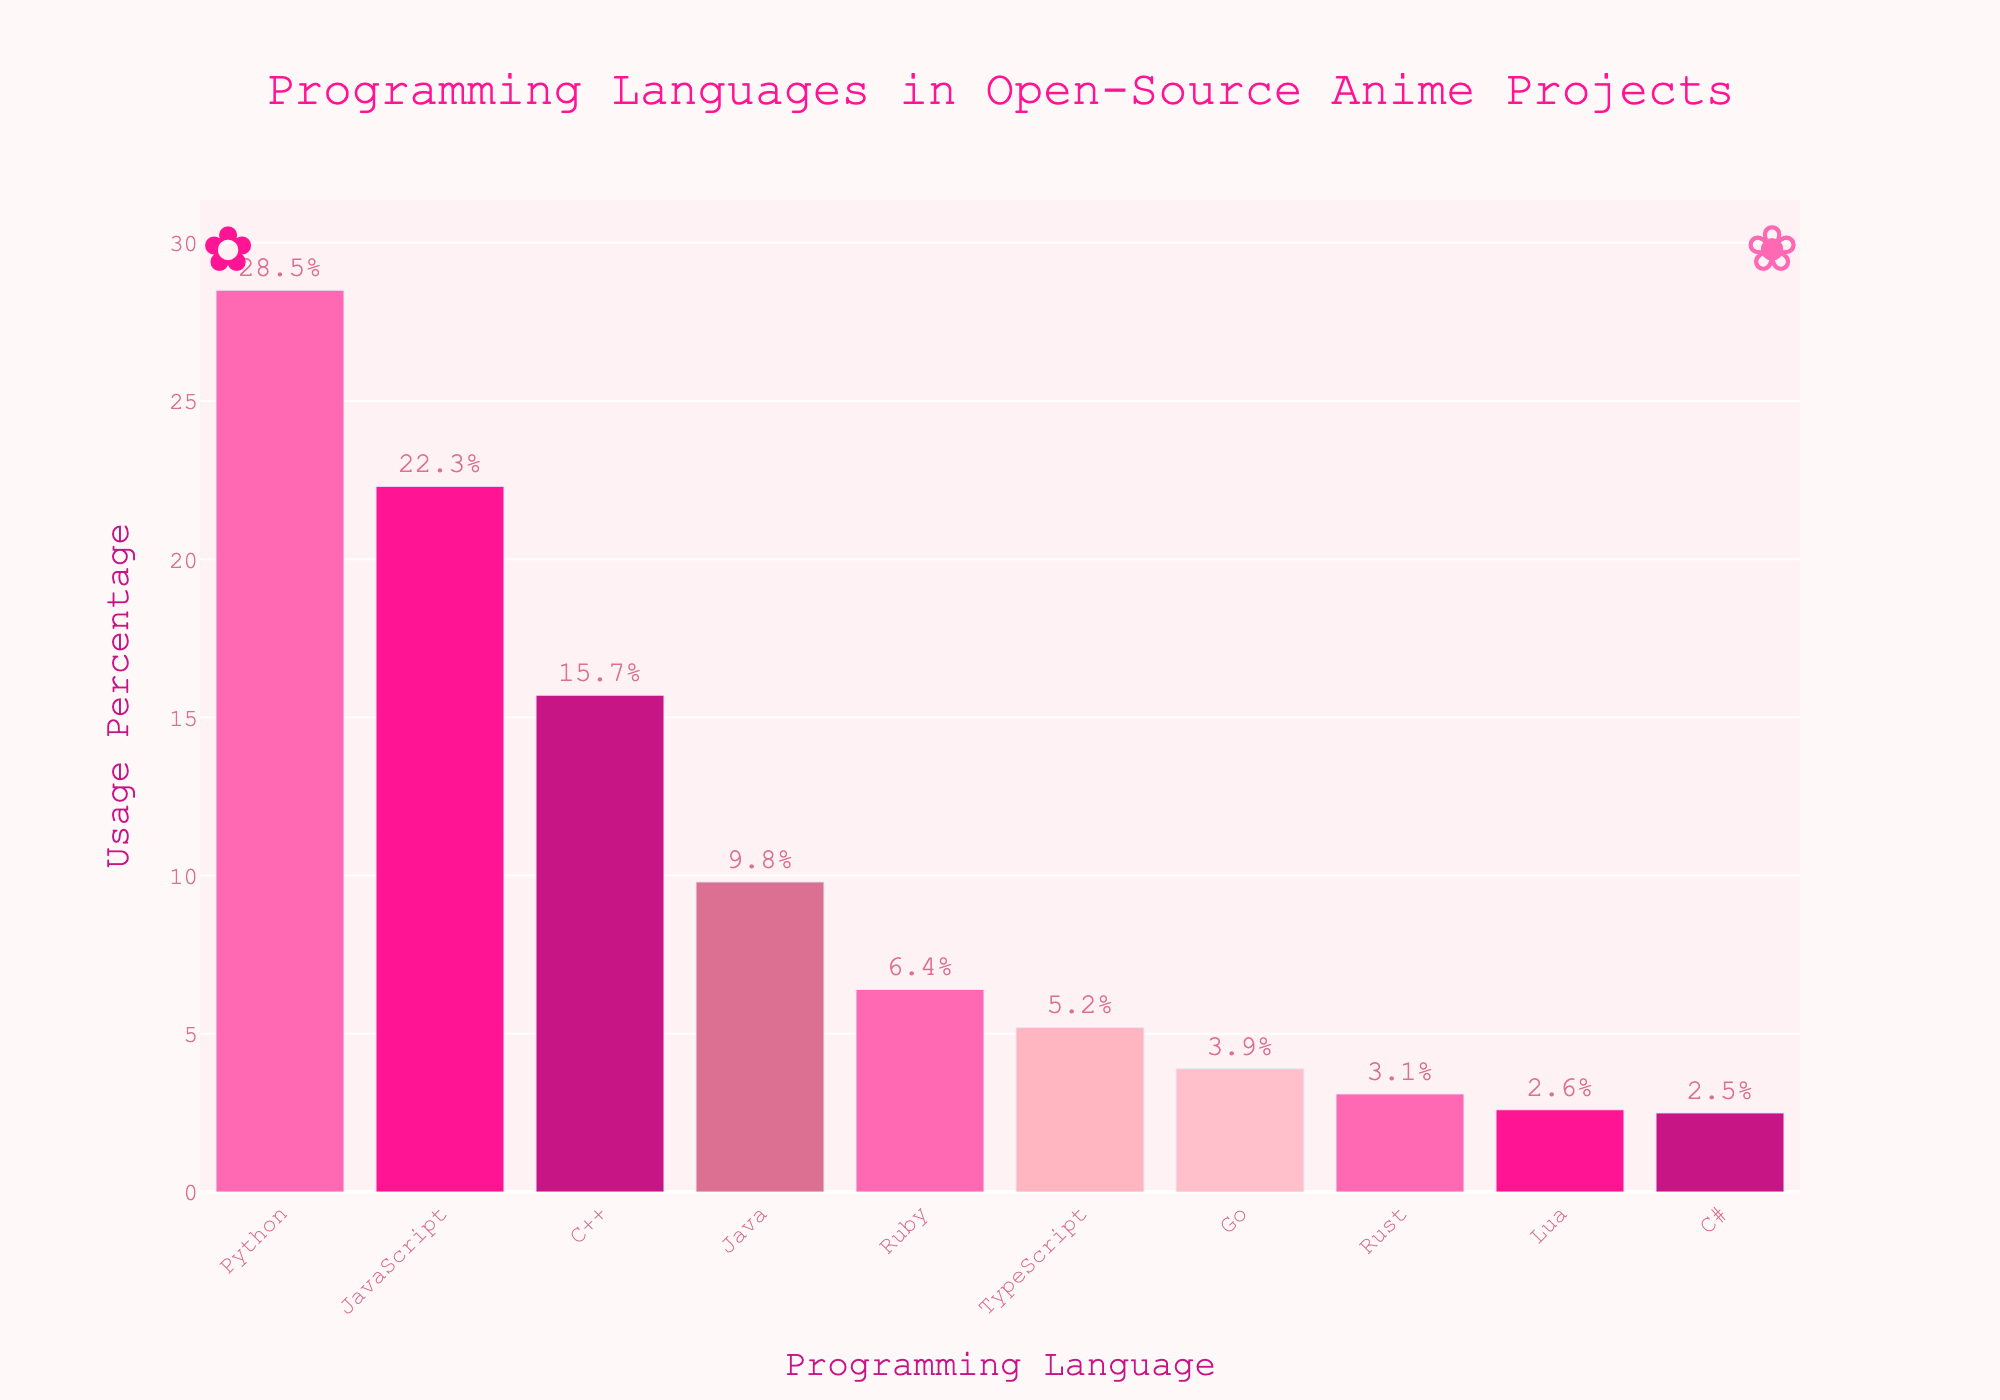Which programming language is used the most in open-source anime-related projects? Observing the bar chart, the tallest bar represents the programming language with the highest usage percentage, which is Python at 28.5%.
Answer: Python Which programming language has a slightly lower usage percentage compared to Python? The bar next to Python in height represents JavaScript, which is the second highest at 22.3%.
Answer: JavaScript What is the combined usage percentage of C++ and Java? The usage percentage of C++ is 15.7% and for Java, it is 9.8%. Adding these together, we get 15.7% + 9.8% = 25.5%.
Answer: 25.5% Out of Ruby and TypeScript, which language has higher usage and by how much? Ruby has a usage percentage of 6.4%, while TypeScript has 5.2%. The difference is 6.4% - 5.2% = 1.2%.
Answer: Ruby by 1.2% What is the overall sum of usage percentages for the top three programming languages? The top three languages by usage percentage are Python (28.5%), JavaScript (22.3%), and C++ (15.7%). The total is 28.5% + 22.3% + 15.7% = 66.5%.
Answer: 66.5% Which programming languages have usage percentages below 4%? The bars representing languages below 4% usage are Go (3.9%), Rust (3.1%), Lua (2.6%), and C# (2.5%).
Answer: Go, Rust, Lua, C# How does the usage of Go compare to Rust and Lua combined? Go has a usage percentage of 3.9%. Rust and Lua together have 3.1% + 2.6% = 5.7%. Thus, Go’s usage is less than Rust and Lua combined.
Answer: Less Which programming language has the fifth highest usage percentage? The fifth highest usage percentage bar corresponds to Ruby with 6.4%.
Answer: Ruby What is the difference in usage percentage between the language with the highest and lowest usage? The highest usage percentage is Python with 28.5%, and the lowest is C# with 2.5%. The difference is 28.5% - 2.5% = 26.0%.
Answer: 26.0% 